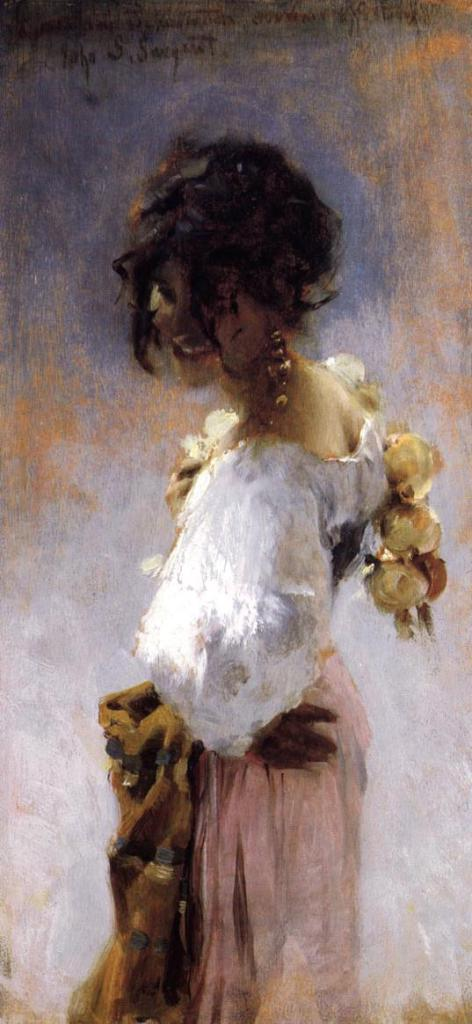What type of artwork is depicted in the image? The image is a painting. Who or what is the main subject of the painting? There is a lady in the painting. What can be seen in the background of the painting? There is a wall in the background of the painting. How many basins are visible in the painting? There are no basins present in the painting; it features a lady and a wall in the background. What type of pin is the lady wearing in the painting? There is no pin visible on the lady in the painting. 